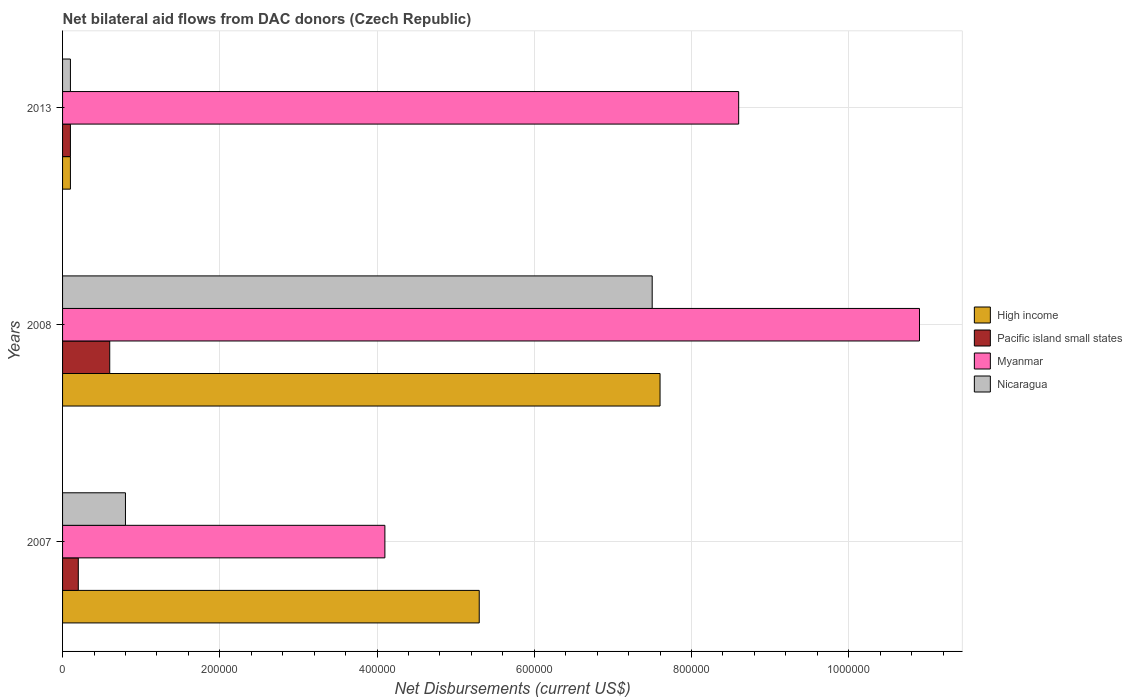How many different coloured bars are there?
Offer a terse response. 4. How many groups of bars are there?
Provide a short and direct response. 3. What is the net bilateral aid flows in Nicaragua in 2008?
Make the answer very short. 7.50e+05. Across all years, what is the maximum net bilateral aid flows in Myanmar?
Offer a terse response. 1.09e+06. Across all years, what is the minimum net bilateral aid flows in Myanmar?
Keep it short and to the point. 4.10e+05. In which year was the net bilateral aid flows in High income maximum?
Provide a succinct answer. 2008. What is the total net bilateral aid flows in High income in the graph?
Provide a succinct answer. 1.30e+06. What is the difference between the net bilateral aid flows in High income in 2008 and that in 2013?
Give a very brief answer. 7.50e+05. What is the difference between the net bilateral aid flows in Myanmar in 2008 and the net bilateral aid flows in High income in 2007?
Keep it short and to the point. 5.60e+05. In the year 2007, what is the difference between the net bilateral aid flows in Pacific island small states and net bilateral aid flows in Nicaragua?
Your answer should be compact. -6.00e+04. In how many years, is the net bilateral aid flows in High income greater than 800000 US$?
Offer a very short reply. 0. What is the ratio of the net bilateral aid flows in Myanmar in 2007 to that in 2008?
Offer a terse response. 0.38. Is the net bilateral aid flows in Pacific island small states in 2007 less than that in 2008?
Provide a short and direct response. Yes. Is the difference between the net bilateral aid flows in Pacific island small states in 2007 and 2013 greater than the difference between the net bilateral aid flows in Nicaragua in 2007 and 2013?
Provide a succinct answer. No. What is the difference between the highest and the lowest net bilateral aid flows in Nicaragua?
Your answer should be compact. 7.40e+05. In how many years, is the net bilateral aid flows in High income greater than the average net bilateral aid flows in High income taken over all years?
Your response must be concise. 2. What does the 4th bar from the top in 2007 represents?
Your response must be concise. High income. What does the 1st bar from the bottom in 2013 represents?
Make the answer very short. High income. Are all the bars in the graph horizontal?
Offer a terse response. Yes. What is the difference between two consecutive major ticks on the X-axis?
Your answer should be very brief. 2.00e+05. Are the values on the major ticks of X-axis written in scientific E-notation?
Offer a very short reply. No. Does the graph contain any zero values?
Offer a terse response. No. Where does the legend appear in the graph?
Your answer should be compact. Center right. What is the title of the graph?
Keep it short and to the point. Net bilateral aid flows from DAC donors (Czech Republic). What is the label or title of the X-axis?
Your answer should be very brief. Net Disbursements (current US$). What is the label or title of the Y-axis?
Provide a succinct answer. Years. What is the Net Disbursements (current US$) in High income in 2007?
Provide a short and direct response. 5.30e+05. What is the Net Disbursements (current US$) of Pacific island small states in 2007?
Your answer should be very brief. 2.00e+04. What is the Net Disbursements (current US$) of Myanmar in 2007?
Provide a short and direct response. 4.10e+05. What is the Net Disbursements (current US$) in Nicaragua in 2007?
Keep it short and to the point. 8.00e+04. What is the Net Disbursements (current US$) of High income in 2008?
Provide a short and direct response. 7.60e+05. What is the Net Disbursements (current US$) of Myanmar in 2008?
Give a very brief answer. 1.09e+06. What is the Net Disbursements (current US$) of Nicaragua in 2008?
Give a very brief answer. 7.50e+05. What is the Net Disbursements (current US$) in High income in 2013?
Ensure brevity in your answer.  10000. What is the Net Disbursements (current US$) of Myanmar in 2013?
Offer a very short reply. 8.60e+05. What is the Net Disbursements (current US$) in Nicaragua in 2013?
Give a very brief answer. 10000. Across all years, what is the maximum Net Disbursements (current US$) of High income?
Make the answer very short. 7.60e+05. Across all years, what is the maximum Net Disbursements (current US$) of Pacific island small states?
Ensure brevity in your answer.  6.00e+04. Across all years, what is the maximum Net Disbursements (current US$) of Myanmar?
Provide a short and direct response. 1.09e+06. Across all years, what is the maximum Net Disbursements (current US$) in Nicaragua?
Offer a very short reply. 7.50e+05. Across all years, what is the minimum Net Disbursements (current US$) of Pacific island small states?
Provide a short and direct response. 10000. Across all years, what is the minimum Net Disbursements (current US$) of Myanmar?
Make the answer very short. 4.10e+05. Across all years, what is the minimum Net Disbursements (current US$) of Nicaragua?
Offer a very short reply. 10000. What is the total Net Disbursements (current US$) in High income in the graph?
Ensure brevity in your answer.  1.30e+06. What is the total Net Disbursements (current US$) of Pacific island small states in the graph?
Give a very brief answer. 9.00e+04. What is the total Net Disbursements (current US$) of Myanmar in the graph?
Keep it short and to the point. 2.36e+06. What is the total Net Disbursements (current US$) in Nicaragua in the graph?
Your answer should be compact. 8.40e+05. What is the difference between the Net Disbursements (current US$) in High income in 2007 and that in 2008?
Provide a succinct answer. -2.30e+05. What is the difference between the Net Disbursements (current US$) in Myanmar in 2007 and that in 2008?
Ensure brevity in your answer.  -6.80e+05. What is the difference between the Net Disbursements (current US$) of Nicaragua in 2007 and that in 2008?
Your answer should be compact. -6.70e+05. What is the difference between the Net Disbursements (current US$) in High income in 2007 and that in 2013?
Your answer should be very brief. 5.20e+05. What is the difference between the Net Disbursements (current US$) in Myanmar in 2007 and that in 2013?
Your answer should be very brief. -4.50e+05. What is the difference between the Net Disbursements (current US$) in Nicaragua in 2007 and that in 2013?
Your answer should be very brief. 7.00e+04. What is the difference between the Net Disbursements (current US$) in High income in 2008 and that in 2013?
Give a very brief answer. 7.50e+05. What is the difference between the Net Disbursements (current US$) of Myanmar in 2008 and that in 2013?
Your answer should be compact. 2.30e+05. What is the difference between the Net Disbursements (current US$) in Nicaragua in 2008 and that in 2013?
Your response must be concise. 7.40e+05. What is the difference between the Net Disbursements (current US$) of High income in 2007 and the Net Disbursements (current US$) of Pacific island small states in 2008?
Offer a very short reply. 4.70e+05. What is the difference between the Net Disbursements (current US$) in High income in 2007 and the Net Disbursements (current US$) in Myanmar in 2008?
Keep it short and to the point. -5.60e+05. What is the difference between the Net Disbursements (current US$) in Pacific island small states in 2007 and the Net Disbursements (current US$) in Myanmar in 2008?
Offer a very short reply. -1.07e+06. What is the difference between the Net Disbursements (current US$) in Pacific island small states in 2007 and the Net Disbursements (current US$) in Nicaragua in 2008?
Make the answer very short. -7.30e+05. What is the difference between the Net Disbursements (current US$) in High income in 2007 and the Net Disbursements (current US$) in Pacific island small states in 2013?
Ensure brevity in your answer.  5.20e+05. What is the difference between the Net Disbursements (current US$) in High income in 2007 and the Net Disbursements (current US$) in Myanmar in 2013?
Make the answer very short. -3.30e+05. What is the difference between the Net Disbursements (current US$) in High income in 2007 and the Net Disbursements (current US$) in Nicaragua in 2013?
Keep it short and to the point. 5.20e+05. What is the difference between the Net Disbursements (current US$) in Pacific island small states in 2007 and the Net Disbursements (current US$) in Myanmar in 2013?
Give a very brief answer. -8.40e+05. What is the difference between the Net Disbursements (current US$) of High income in 2008 and the Net Disbursements (current US$) of Pacific island small states in 2013?
Keep it short and to the point. 7.50e+05. What is the difference between the Net Disbursements (current US$) in High income in 2008 and the Net Disbursements (current US$) in Myanmar in 2013?
Offer a very short reply. -1.00e+05. What is the difference between the Net Disbursements (current US$) in High income in 2008 and the Net Disbursements (current US$) in Nicaragua in 2013?
Offer a terse response. 7.50e+05. What is the difference between the Net Disbursements (current US$) of Pacific island small states in 2008 and the Net Disbursements (current US$) of Myanmar in 2013?
Your response must be concise. -8.00e+05. What is the difference between the Net Disbursements (current US$) in Pacific island small states in 2008 and the Net Disbursements (current US$) in Nicaragua in 2013?
Offer a very short reply. 5.00e+04. What is the difference between the Net Disbursements (current US$) of Myanmar in 2008 and the Net Disbursements (current US$) of Nicaragua in 2013?
Provide a succinct answer. 1.08e+06. What is the average Net Disbursements (current US$) of High income per year?
Keep it short and to the point. 4.33e+05. What is the average Net Disbursements (current US$) of Pacific island small states per year?
Keep it short and to the point. 3.00e+04. What is the average Net Disbursements (current US$) of Myanmar per year?
Your answer should be compact. 7.87e+05. What is the average Net Disbursements (current US$) of Nicaragua per year?
Provide a short and direct response. 2.80e+05. In the year 2007, what is the difference between the Net Disbursements (current US$) in High income and Net Disbursements (current US$) in Pacific island small states?
Your answer should be compact. 5.10e+05. In the year 2007, what is the difference between the Net Disbursements (current US$) of High income and Net Disbursements (current US$) of Myanmar?
Keep it short and to the point. 1.20e+05. In the year 2007, what is the difference between the Net Disbursements (current US$) in High income and Net Disbursements (current US$) in Nicaragua?
Give a very brief answer. 4.50e+05. In the year 2007, what is the difference between the Net Disbursements (current US$) of Pacific island small states and Net Disbursements (current US$) of Myanmar?
Your answer should be compact. -3.90e+05. In the year 2007, what is the difference between the Net Disbursements (current US$) in Pacific island small states and Net Disbursements (current US$) in Nicaragua?
Provide a short and direct response. -6.00e+04. In the year 2008, what is the difference between the Net Disbursements (current US$) in High income and Net Disbursements (current US$) in Pacific island small states?
Ensure brevity in your answer.  7.00e+05. In the year 2008, what is the difference between the Net Disbursements (current US$) of High income and Net Disbursements (current US$) of Myanmar?
Offer a very short reply. -3.30e+05. In the year 2008, what is the difference between the Net Disbursements (current US$) in High income and Net Disbursements (current US$) in Nicaragua?
Provide a short and direct response. 10000. In the year 2008, what is the difference between the Net Disbursements (current US$) in Pacific island small states and Net Disbursements (current US$) in Myanmar?
Provide a succinct answer. -1.03e+06. In the year 2008, what is the difference between the Net Disbursements (current US$) of Pacific island small states and Net Disbursements (current US$) of Nicaragua?
Give a very brief answer. -6.90e+05. In the year 2008, what is the difference between the Net Disbursements (current US$) in Myanmar and Net Disbursements (current US$) in Nicaragua?
Your answer should be compact. 3.40e+05. In the year 2013, what is the difference between the Net Disbursements (current US$) of High income and Net Disbursements (current US$) of Pacific island small states?
Your response must be concise. 0. In the year 2013, what is the difference between the Net Disbursements (current US$) in High income and Net Disbursements (current US$) in Myanmar?
Keep it short and to the point. -8.50e+05. In the year 2013, what is the difference between the Net Disbursements (current US$) in High income and Net Disbursements (current US$) in Nicaragua?
Provide a short and direct response. 0. In the year 2013, what is the difference between the Net Disbursements (current US$) of Pacific island small states and Net Disbursements (current US$) of Myanmar?
Keep it short and to the point. -8.50e+05. In the year 2013, what is the difference between the Net Disbursements (current US$) of Pacific island small states and Net Disbursements (current US$) of Nicaragua?
Offer a very short reply. 0. In the year 2013, what is the difference between the Net Disbursements (current US$) of Myanmar and Net Disbursements (current US$) of Nicaragua?
Your answer should be compact. 8.50e+05. What is the ratio of the Net Disbursements (current US$) of High income in 2007 to that in 2008?
Your answer should be very brief. 0.7. What is the ratio of the Net Disbursements (current US$) in Pacific island small states in 2007 to that in 2008?
Offer a very short reply. 0.33. What is the ratio of the Net Disbursements (current US$) in Myanmar in 2007 to that in 2008?
Offer a very short reply. 0.38. What is the ratio of the Net Disbursements (current US$) of Nicaragua in 2007 to that in 2008?
Your answer should be very brief. 0.11. What is the ratio of the Net Disbursements (current US$) of Pacific island small states in 2007 to that in 2013?
Your answer should be very brief. 2. What is the ratio of the Net Disbursements (current US$) in Myanmar in 2007 to that in 2013?
Provide a succinct answer. 0.48. What is the ratio of the Net Disbursements (current US$) in Nicaragua in 2007 to that in 2013?
Your answer should be compact. 8. What is the ratio of the Net Disbursements (current US$) in Pacific island small states in 2008 to that in 2013?
Your answer should be compact. 6. What is the ratio of the Net Disbursements (current US$) in Myanmar in 2008 to that in 2013?
Ensure brevity in your answer.  1.27. What is the ratio of the Net Disbursements (current US$) of Nicaragua in 2008 to that in 2013?
Give a very brief answer. 75. What is the difference between the highest and the second highest Net Disbursements (current US$) in Pacific island small states?
Give a very brief answer. 4.00e+04. What is the difference between the highest and the second highest Net Disbursements (current US$) of Myanmar?
Keep it short and to the point. 2.30e+05. What is the difference between the highest and the second highest Net Disbursements (current US$) of Nicaragua?
Provide a succinct answer. 6.70e+05. What is the difference between the highest and the lowest Net Disbursements (current US$) of High income?
Your answer should be compact. 7.50e+05. What is the difference between the highest and the lowest Net Disbursements (current US$) of Pacific island small states?
Give a very brief answer. 5.00e+04. What is the difference between the highest and the lowest Net Disbursements (current US$) of Myanmar?
Give a very brief answer. 6.80e+05. What is the difference between the highest and the lowest Net Disbursements (current US$) in Nicaragua?
Your answer should be compact. 7.40e+05. 